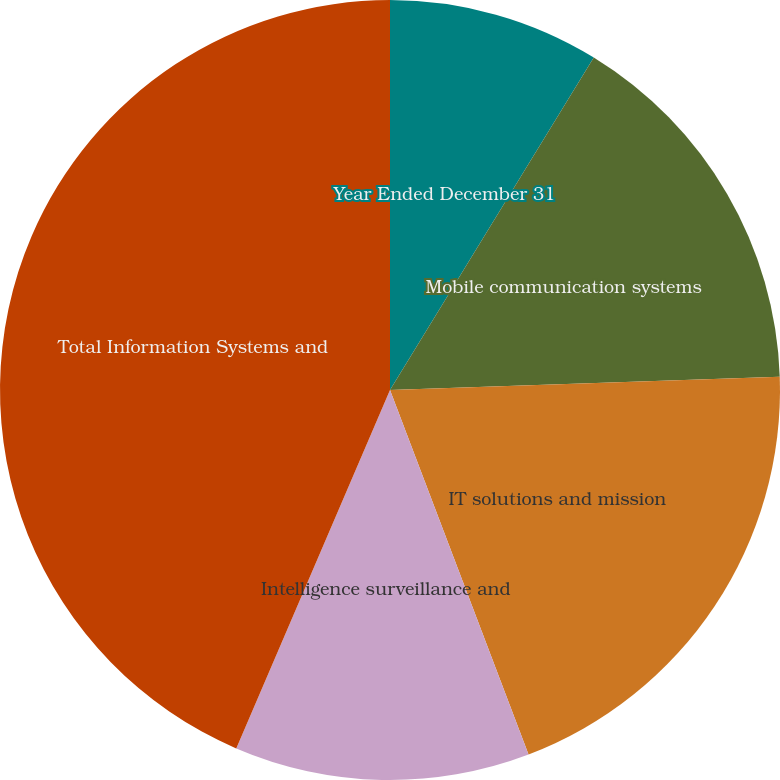Convert chart to OTSL. <chart><loc_0><loc_0><loc_500><loc_500><pie_chart><fcel>Year Ended December 31<fcel>Mobile communication systems<fcel>IT solutions and mission<fcel>Intelligence surveillance and<fcel>Total Information Systems and<nl><fcel>8.75%<fcel>15.71%<fcel>19.76%<fcel>12.23%<fcel>43.55%<nl></chart> 